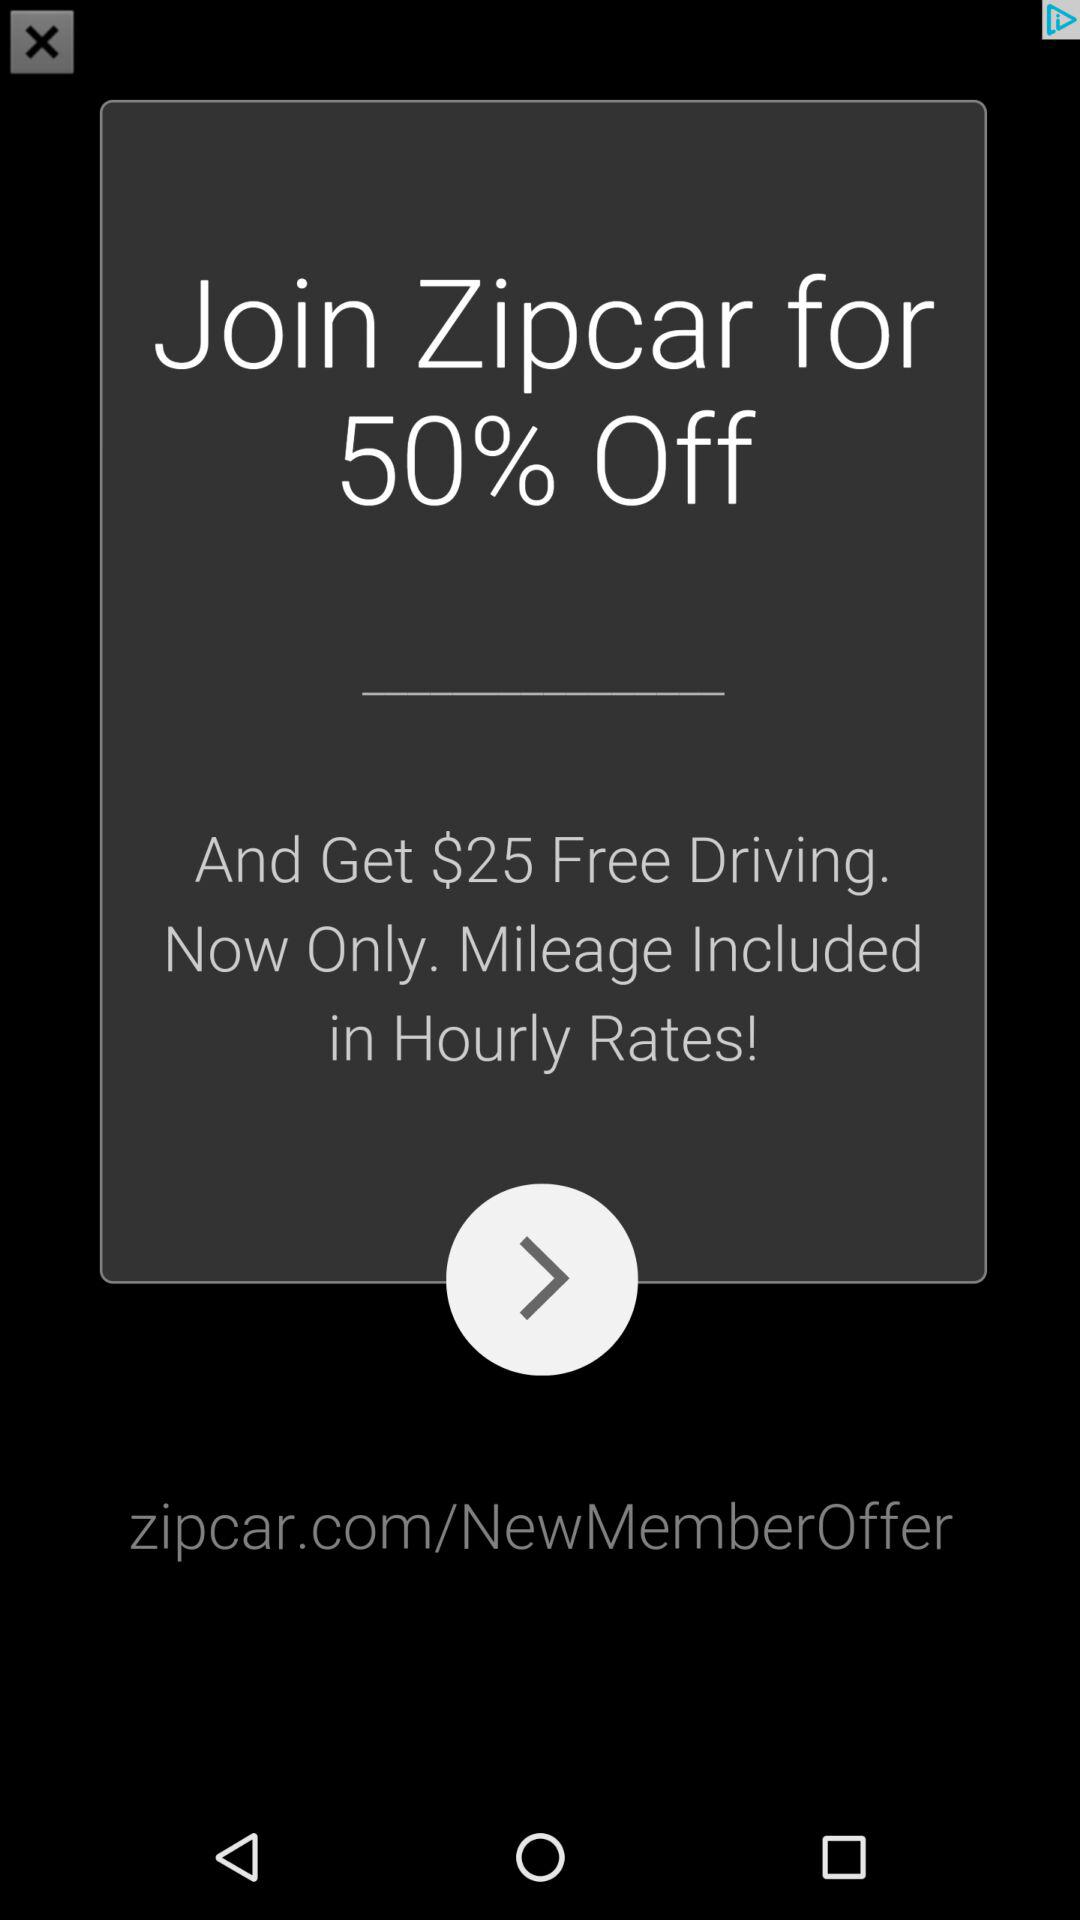How many dollars more free driving do you get if you sign up now versus later?
Answer the question using a single word or phrase. $25 